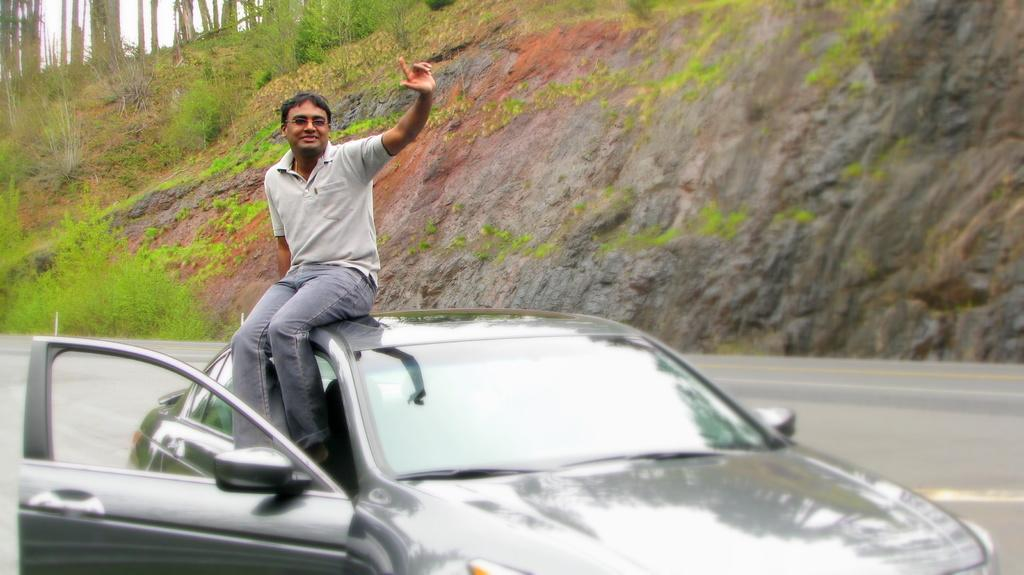Who is in the image? There is a man in the image. What is the man wearing? The man is wearing a grey t-shirt and jeans. What is the man doing in the image? The man is sitting on a car. What can be seen in the background of the image? There is an inclined land in the background of the image, with plants and grass present. What type of plate is being smashed by the man in the image? There is no plate or smashing activity present in the image. Is there a train visible in the image? No, there is no train present in the image. 